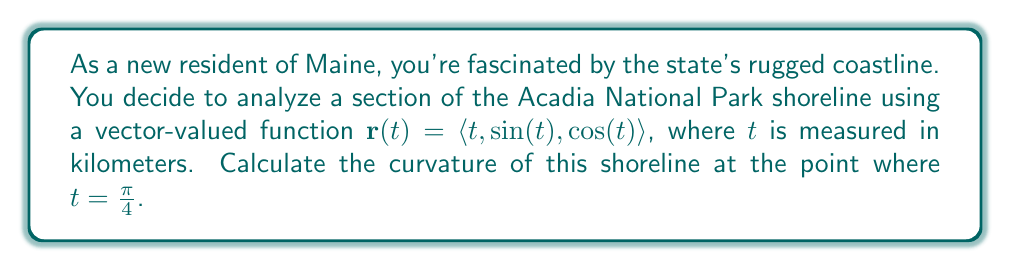Can you answer this question? To find the curvature of the shoreline, we'll use the formula for curvature of a vector-valued function:

$$\kappa = \frac{|\mathbf{r}'(t) \times \mathbf{r}''(t)|}{|\mathbf{r}'(t)|^3}$$

Step 1: Calculate $\mathbf{r}'(t)$
$$\mathbf{r}'(t) = \langle 1, \cos(t), -\sin(t) \rangle$$

Step 2: Calculate $\mathbf{r}''(t)$
$$\mathbf{r}''(t) = \langle 0, -\sin(t), -\cos(t) \rangle$$

Step 3: Calculate $\mathbf{r}'(t) \times \mathbf{r}''(t)$
$$\begin{align*}
\mathbf{r}'(t) \times \mathbf{r}''(t) &= \begin{vmatrix}
\mathbf{i} & \mathbf{j} & \mathbf{k} \\
1 & \cos(t) & -\sin(t) \\
0 & -\sin(t) & -\cos(t)
\end{vmatrix} \\
&= \langle -\cos^2(t) - \sin^2(t), \sin(t), -\cos(t) \rangle \\
&= \langle -1, \sin(t), -\cos(t) \rangle
\end{align*}$$

Step 4: Calculate $|\mathbf{r}'(t) \times \mathbf{r}''(t)|$
$$|\mathbf{r}'(t) \times \mathbf{r}''(t)| = \sqrt{(-1)^2 + \sin^2(t) + \cos^2(t)} = \sqrt{2}$$

Step 5: Calculate $|\mathbf{r}'(t)|$
$$|\mathbf{r}'(t)| = \sqrt{1^2 + \cos^2(t) + \sin^2(t)} = \sqrt{2}$$

Step 6: Apply the curvature formula at $t = \frac{\pi}{4}$
$$\kappa = \frac{|\mathbf{r}'(\frac{\pi}{4}) \times \mathbf{r}''(\frac{\pi}{4})|}{|\mathbf{r}'(\frac{\pi}{4})|^3} = \frac{\sqrt{2}}{(\sqrt{2})^3} = \frac{1}{2}$$
Answer: The curvature of the shoreline at $t = \frac{\pi}{4}$ is $\frac{1}{2}$ km$^{-1}$. 